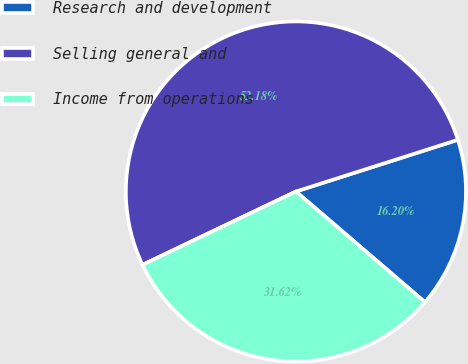<chart> <loc_0><loc_0><loc_500><loc_500><pie_chart><fcel>Research and development<fcel>Selling general and<fcel>Income from operations<nl><fcel>16.2%<fcel>52.18%<fcel>31.62%<nl></chart> 